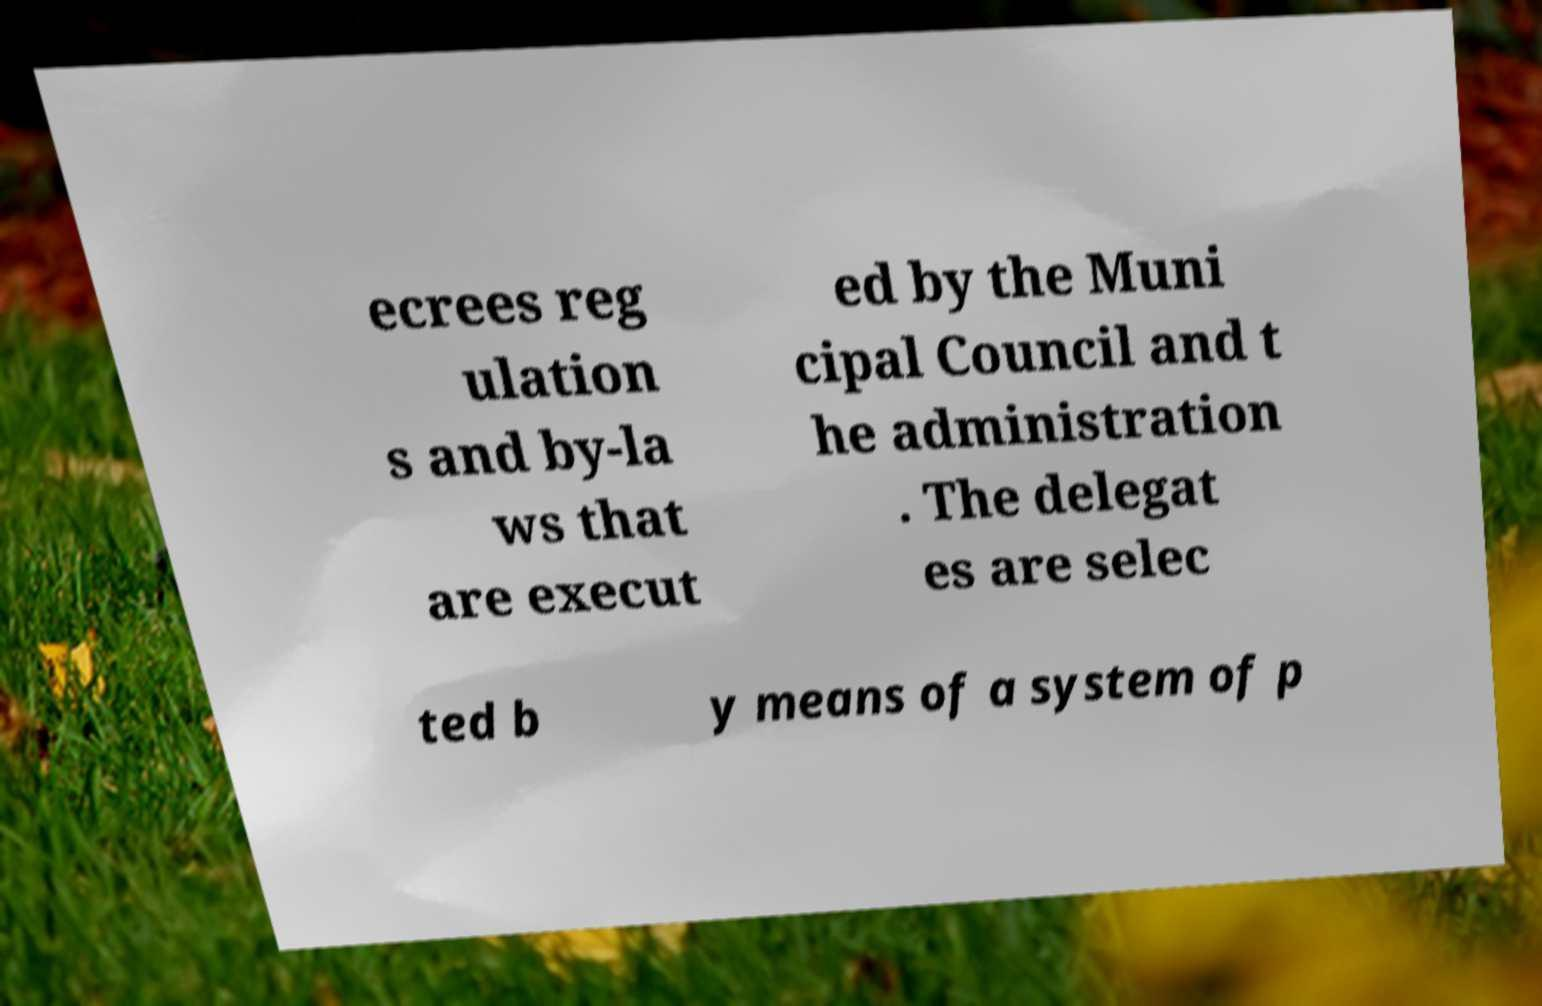Please read and relay the text visible in this image. What does it say? ecrees reg ulation s and by-la ws that are execut ed by the Muni cipal Council and t he administration . The delegat es are selec ted b y means of a system of p 